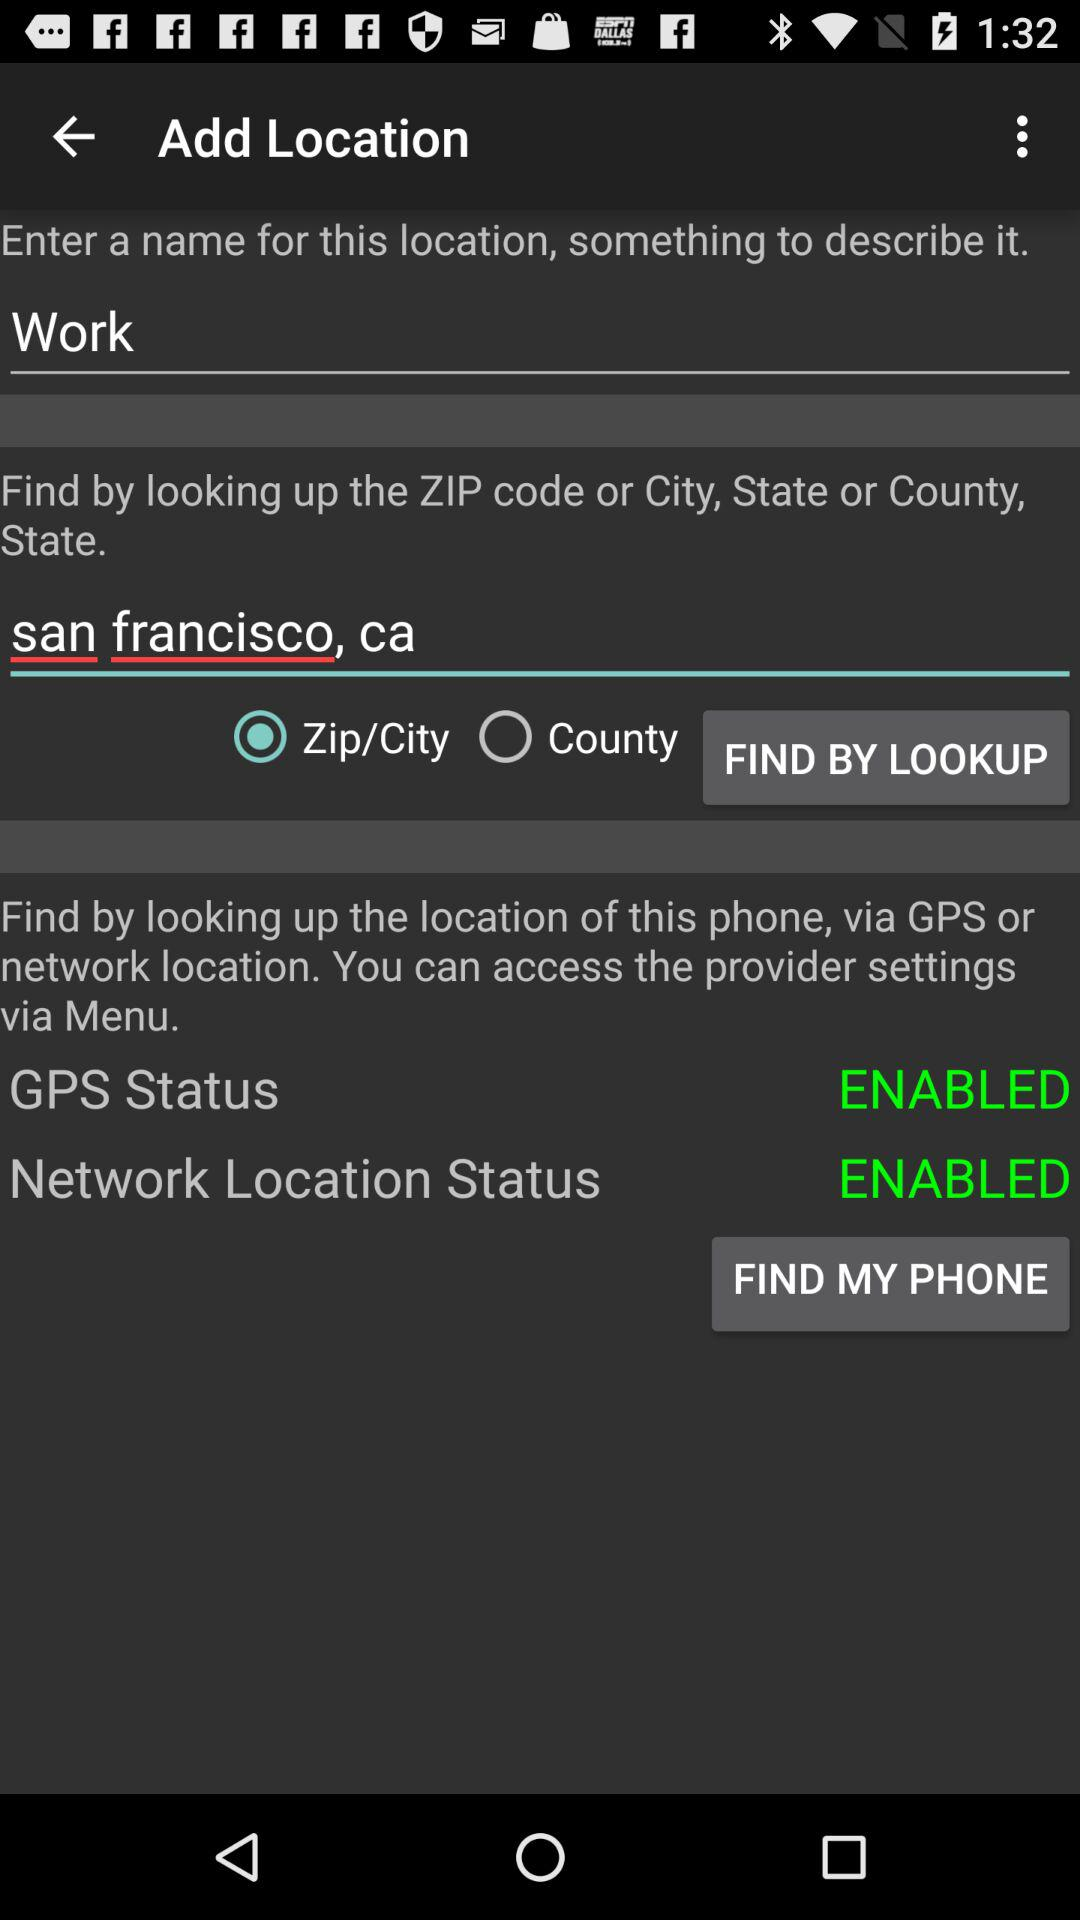Which option has been selected from "FIND BY LOOKUP"? The option that has been selected is "Zip/City". 